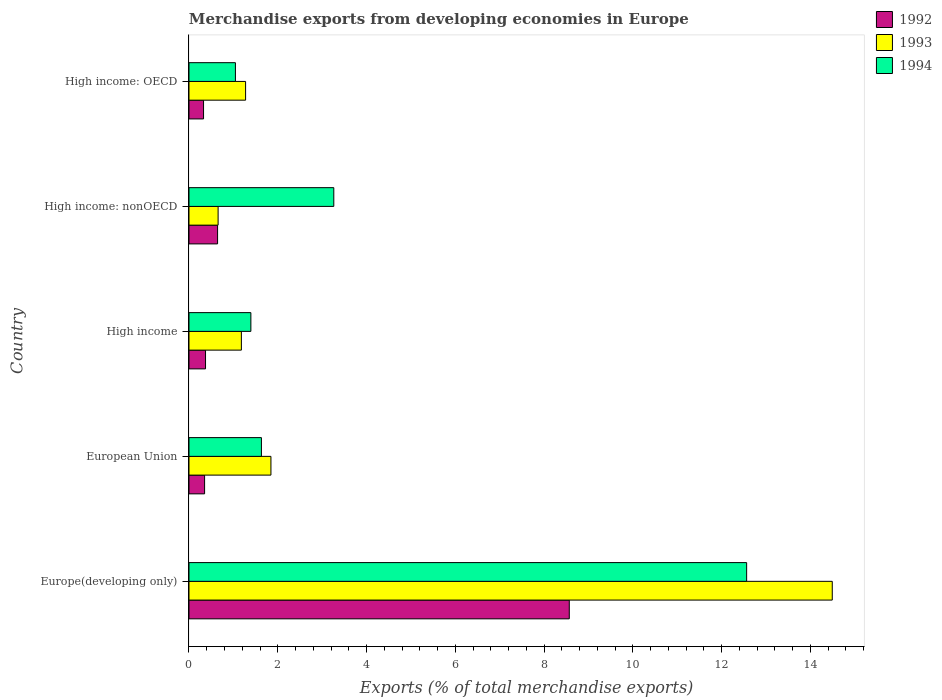How many different coloured bars are there?
Provide a short and direct response. 3. How many groups of bars are there?
Offer a terse response. 5. Are the number of bars per tick equal to the number of legend labels?
Your response must be concise. Yes. Are the number of bars on each tick of the Y-axis equal?
Your answer should be compact. Yes. How many bars are there on the 5th tick from the top?
Keep it short and to the point. 3. How many bars are there on the 5th tick from the bottom?
Keep it short and to the point. 3. What is the label of the 2nd group of bars from the top?
Keep it short and to the point. High income: nonOECD. What is the percentage of total merchandise exports in 1994 in High income: OECD?
Make the answer very short. 1.05. Across all countries, what is the maximum percentage of total merchandise exports in 1994?
Give a very brief answer. 12.57. Across all countries, what is the minimum percentage of total merchandise exports in 1992?
Provide a short and direct response. 0.33. In which country was the percentage of total merchandise exports in 1993 maximum?
Offer a terse response. Europe(developing only). In which country was the percentage of total merchandise exports in 1994 minimum?
Keep it short and to the point. High income: OECD. What is the total percentage of total merchandise exports in 1993 in the graph?
Make the answer very short. 19.45. What is the difference between the percentage of total merchandise exports in 1994 in High income and that in High income: nonOECD?
Ensure brevity in your answer.  -1.87. What is the difference between the percentage of total merchandise exports in 1993 in High income: OECD and the percentage of total merchandise exports in 1992 in European Union?
Provide a short and direct response. 0.92. What is the average percentage of total merchandise exports in 1992 per country?
Offer a very short reply. 2.05. What is the difference between the percentage of total merchandise exports in 1993 and percentage of total merchandise exports in 1994 in European Union?
Offer a terse response. 0.21. In how many countries, is the percentage of total merchandise exports in 1994 greater than 11.6 %?
Your answer should be very brief. 1. What is the ratio of the percentage of total merchandise exports in 1993 in High income to that in High income: OECD?
Offer a very short reply. 0.93. Is the percentage of total merchandise exports in 1993 in Europe(developing only) less than that in European Union?
Keep it short and to the point. No. What is the difference between the highest and the second highest percentage of total merchandise exports in 1994?
Your answer should be compact. 9.3. What is the difference between the highest and the lowest percentage of total merchandise exports in 1993?
Offer a terse response. 13.84. In how many countries, is the percentage of total merchandise exports in 1992 greater than the average percentage of total merchandise exports in 1992 taken over all countries?
Give a very brief answer. 1. What does the 2nd bar from the top in Europe(developing only) represents?
Keep it short and to the point. 1993. Is it the case that in every country, the sum of the percentage of total merchandise exports in 1992 and percentage of total merchandise exports in 1994 is greater than the percentage of total merchandise exports in 1993?
Offer a terse response. Yes. Are all the bars in the graph horizontal?
Keep it short and to the point. Yes. How many countries are there in the graph?
Make the answer very short. 5. What is the difference between two consecutive major ticks on the X-axis?
Your answer should be compact. 2. How are the legend labels stacked?
Offer a very short reply. Vertical. What is the title of the graph?
Make the answer very short. Merchandise exports from developing economies in Europe. Does "1977" appear as one of the legend labels in the graph?
Your answer should be compact. No. What is the label or title of the X-axis?
Offer a very short reply. Exports (% of total merchandise exports). What is the label or title of the Y-axis?
Offer a terse response. Country. What is the Exports (% of total merchandise exports) of 1992 in Europe(developing only)?
Give a very brief answer. 8.57. What is the Exports (% of total merchandise exports) in 1993 in Europe(developing only)?
Your answer should be very brief. 14.5. What is the Exports (% of total merchandise exports) in 1994 in Europe(developing only)?
Make the answer very short. 12.57. What is the Exports (% of total merchandise exports) in 1992 in European Union?
Make the answer very short. 0.35. What is the Exports (% of total merchandise exports) of 1993 in European Union?
Your answer should be very brief. 1.85. What is the Exports (% of total merchandise exports) of 1994 in European Union?
Give a very brief answer. 1.63. What is the Exports (% of total merchandise exports) in 1992 in High income?
Your answer should be compact. 0.37. What is the Exports (% of total merchandise exports) in 1993 in High income?
Give a very brief answer. 1.18. What is the Exports (% of total merchandise exports) in 1994 in High income?
Provide a short and direct response. 1.39. What is the Exports (% of total merchandise exports) in 1992 in High income: nonOECD?
Your response must be concise. 0.64. What is the Exports (% of total merchandise exports) in 1993 in High income: nonOECD?
Offer a terse response. 0.66. What is the Exports (% of total merchandise exports) of 1994 in High income: nonOECD?
Offer a terse response. 3.26. What is the Exports (% of total merchandise exports) in 1992 in High income: OECD?
Keep it short and to the point. 0.33. What is the Exports (% of total merchandise exports) of 1993 in High income: OECD?
Your answer should be very brief. 1.28. What is the Exports (% of total merchandise exports) in 1994 in High income: OECD?
Ensure brevity in your answer.  1.05. Across all countries, what is the maximum Exports (% of total merchandise exports) of 1992?
Your answer should be compact. 8.57. Across all countries, what is the maximum Exports (% of total merchandise exports) in 1993?
Your response must be concise. 14.5. Across all countries, what is the maximum Exports (% of total merchandise exports) of 1994?
Offer a terse response. 12.57. Across all countries, what is the minimum Exports (% of total merchandise exports) of 1992?
Provide a succinct answer. 0.33. Across all countries, what is the minimum Exports (% of total merchandise exports) in 1993?
Keep it short and to the point. 0.66. Across all countries, what is the minimum Exports (% of total merchandise exports) in 1994?
Your response must be concise. 1.05. What is the total Exports (% of total merchandise exports) of 1992 in the graph?
Provide a succinct answer. 10.27. What is the total Exports (% of total merchandise exports) in 1993 in the graph?
Provide a succinct answer. 19.45. What is the total Exports (% of total merchandise exports) in 1994 in the graph?
Your answer should be compact. 19.9. What is the difference between the Exports (% of total merchandise exports) of 1992 in Europe(developing only) and that in European Union?
Your response must be concise. 8.22. What is the difference between the Exports (% of total merchandise exports) in 1993 in Europe(developing only) and that in European Union?
Make the answer very short. 12.65. What is the difference between the Exports (% of total merchandise exports) of 1994 in Europe(developing only) and that in European Union?
Provide a short and direct response. 10.93. What is the difference between the Exports (% of total merchandise exports) in 1992 in Europe(developing only) and that in High income?
Provide a succinct answer. 8.2. What is the difference between the Exports (% of total merchandise exports) in 1993 in Europe(developing only) and that in High income?
Your response must be concise. 13.31. What is the difference between the Exports (% of total merchandise exports) of 1994 in Europe(developing only) and that in High income?
Your answer should be compact. 11.17. What is the difference between the Exports (% of total merchandise exports) of 1992 in Europe(developing only) and that in High income: nonOECD?
Offer a very short reply. 7.92. What is the difference between the Exports (% of total merchandise exports) of 1993 in Europe(developing only) and that in High income: nonOECD?
Give a very brief answer. 13.84. What is the difference between the Exports (% of total merchandise exports) in 1994 in Europe(developing only) and that in High income: nonOECD?
Your answer should be very brief. 9.3. What is the difference between the Exports (% of total merchandise exports) of 1992 in Europe(developing only) and that in High income: OECD?
Keep it short and to the point. 8.24. What is the difference between the Exports (% of total merchandise exports) of 1993 in Europe(developing only) and that in High income: OECD?
Your answer should be compact. 13.22. What is the difference between the Exports (% of total merchandise exports) of 1994 in Europe(developing only) and that in High income: OECD?
Ensure brevity in your answer.  11.52. What is the difference between the Exports (% of total merchandise exports) in 1992 in European Union and that in High income?
Offer a terse response. -0.02. What is the difference between the Exports (% of total merchandise exports) of 1993 in European Union and that in High income?
Your response must be concise. 0.67. What is the difference between the Exports (% of total merchandise exports) of 1994 in European Union and that in High income?
Your answer should be compact. 0.24. What is the difference between the Exports (% of total merchandise exports) in 1992 in European Union and that in High income: nonOECD?
Your answer should be compact. -0.29. What is the difference between the Exports (% of total merchandise exports) in 1993 in European Union and that in High income: nonOECD?
Keep it short and to the point. 1.19. What is the difference between the Exports (% of total merchandise exports) of 1994 in European Union and that in High income: nonOECD?
Give a very brief answer. -1.63. What is the difference between the Exports (% of total merchandise exports) of 1992 in European Union and that in High income: OECD?
Give a very brief answer. 0.02. What is the difference between the Exports (% of total merchandise exports) in 1993 in European Union and that in High income: OECD?
Provide a short and direct response. 0.57. What is the difference between the Exports (% of total merchandise exports) in 1994 in European Union and that in High income: OECD?
Your response must be concise. 0.59. What is the difference between the Exports (% of total merchandise exports) of 1992 in High income and that in High income: nonOECD?
Offer a terse response. -0.27. What is the difference between the Exports (% of total merchandise exports) in 1993 in High income and that in High income: nonOECD?
Give a very brief answer. 0.52. What is the difference between the Exports (% of total merchandise exports) of 1994 in High income and that in High income: nonOECD?
Provide a succinct answer. -1.87. What is the difference between the Exports (% of total merchandise exports) of 1992 in High income and that in High income: OECD?
Provide a short and direct response. 0.04. What is the difference between the Exports (% of total merchandise exports) in 1993 in High income and that in High income: OECD?
Your answer should be very brief. -0.09. What is the difference between the Exports (% of total merchandise exports) in 1994 in High income and that in High income: OECD?
Keep it short and to the point. 0.35. What is the difference between the Exports (% of total merchandise exports) of 1992 in High income: nonOECD and that in High income: OECD?
Ensure brevity in your answer.  0.32. What is the difference between the Exports (% of total merchandise exports) in 1993 in High income: nonOECD and that in High income: OECD?
Your answer should be very brief. -0.62. What is the difference between the Exports (% of total merchandise exports) in 1994 in High income: nonOECD and that in High income: OECD?
Make the answer very short. 2.22. What is the difference between the Exports (% of total merchandise exports) in 1992 in Europe(developing only) and the Exports (% of total merchandise exports) in 1993 in European Union?
Offer a terse response. 6.72. What is the difference between the Exports (% of total merchandise exports) in 1992 in Europe(developing only) and the Exports (% of total merchandise exports) in 1994 in European Union?
Provide a short and direct response. 6.94. What is the difference between the Exports (% of total merchandise exports) in 1993 in Europe(developing only) and the Exports (% of total merchandise exports) in 1994 in European Union?
Make the answer very short. 12.86. What is the difference between the Exports (% of total merchandise exports) in 1992 in Europe(developing only) and the Exports (% of total merchandise exports) in 1993 in High income?
Provide a short and direct response. 7.39. What is the difference between the Exports (% of total merchandise exports) in 1992 in Europe(developing only) and the Exports (% of total merchandise exports) in 1994 in High income?
Ensure brevity in your answer.  7.17. What is the difference between the Exports (% of total merchandise exports) in 1993 in Europe(developing only) and the Exports (% of total merchandise exports) in 1994 in High income?
Offer a very short reply. 13.1. What is the difference between the Exports (% of total merchandise exports) in 1992 in Europe(developing only) and the Exports (% of total merchandise exports) in 1993 in High income: nonOECD?
Your answer should be very brief. 7.91. What is the difference between the Exports (% of total merchandise exports) of 1992 in Europe(developing only) and the Exports (% of total merchandise exports) of 1994 in High income: nonOECD?
Provide a short and direct response. 5.31. What is the difference between the Exports (% of total merchandise exports) in 1993 in Europe(developing only) and the Exports (% of total merchandise exports) in 1994 in High income: nonOECD?
Ensure brevity in your answer.  11.23. What is the difference between the Exports (% of total merchandise exports) of 1992 in Europe(developing only) and the Exports (% of total merchandise exports) of 1993 in High income: OECD?
Keep it short and to the point. 7.29. What is the difference between the Exports (% of total merchandise exports) of 1992 in Europe(developing only) and the Exports (% of total merchandise exports) of 1994 in High income: OECD?
Your answer should be compact. 7.52. What is the difference between the Exports (% of total merchandise exports) of 1993 in Europe(developing only) and the Exports (% of total merchandise exports) of 1994 in High income: OECD?
Offer a terse response. 13.45. What is the difference between the Exports (% of total merchandise exports) of 1992 in European Union and the Exports (% of total merchandise exports) of 1993 in High income?
Your response must be concise. -0.83. What is the difference between the Exports (% of total merchandise exports) of 1992 in European Union and the Exports (% of total merchandise exports) of 1994 in High income?
Give a very brief answer. -1.04. What is the difference between the Exports (% of total merchandise exports) of 1993 in European Union and the Exports (% of total merchandise exports) of 1994 in High income?
Offer a very short reply. 0.45. What is the difference between the Exports (% of total merchandise exports) in 1992 in European Union and the Exports (% of total merchandise exports) in 1993 in High income: nonOECD?
Give a very brief answer. -0.3. What is the difference between the Exports (% of total merchandise exports) of 1992 in European Union and the Exports (% of total merchandise exports) of 1994 in High income: nonOECD?
Your response must be concise. -2.91. What is the difference between the Exports (% of total merchandise exports) in 1993 in European Union and the Exports (% of total merchandise exports) in 1994 in High income: nonOECD?
Offer a very short reply. -1.42. What is the difference between the Exports (% of total merchandise exports) of 1992 in European Union and the Exports (% of total merchandise exports) of 1993 in High income: OECD?
Give a very brief answer. -0.92. What is the difference between the Exports (% of total merchandise exports) of 1992 in European Union and the Exports (% of total merchandise exports) of 1994 in High income: OECD?
Your answer should be compact. -0.69. What is the difference between the Exports (% of total merchandise exports) in 1993 in European Union and the Exports (% of total merchandise exports) in 1994 in High income: OECD?
Ensure brevity in your answer.  0.8. What is the difference between the Exports (% of total merchandise exports) of 1992 in High income and the Exports (% of total merchandise exports) of 1993 in High income: nonOECD?
Provide a succinct answer. -0.28. What is the difference between the Exports (% of total merchandise exports) of 1992 in High income and the Exports (% of total merchandise exports) of 1994 in High income: nonOECD?
Ensure brevity in your answer.  -2.89. What is the difference between the Exports (% of total merchandise exports) in 1993 in High income and the Exports (% of total merchandise exports) in 1994 in High income: nonOECD?
Provide a short and direct response. -2.08. What is the difference between the Exports (% of total merchandise exports) of 1992 in High income and the Exports (% of total merchandise exports) of 1993 in High income: OECD?
Your answer should be very brief. -0.9. What is the difference between the Exports (% of total merchandise exports) in 1992 in High income and the Exports (% of total merchandise exports) in 1994 in High income: OECD?
Provide a short and direct response. -0.67. What is the difference between the Exports (% of total merchandise exports) of 1993 in High income and the Exports (% of total merchandise exports) of 1994 in High income: OECD?
Your answer should be very brief. 0.13. What is the difference between the Exports (% of total merchandise exports) of 1992 in High income: nonOECD and the Exports (% of total merchandise exports) of 1993 in High income: OECD?
Provide a succinct answer. -0.63. What is the difference between the Exports (% of total merchandise exports) of 1992 in High income: nonOECD and the Exports (% of total merchandise exports) of 1994 in High income: OECD?
Give a very brief answer. -0.4. What is the difference between the Exports (% of total merchandise exports) in 1993 in High income: nonOECD and the Exports (% of total merchandise exports) in 1994 in High income: OECD?
Your answer should be very brief. -0.39. What is the average Exports (% of total merchandise exports) in 1992 per country?
Provide a succinct answer. 2.05. What is the average Exports (% of total merchandise exports) in 1993 per country?
Your response must be concise. 3.89. What is the average Exports (% of total merchandise exports) of 1994 per country?
Make the answer very short. 3.98. What is the difference between the Exports (% of total merchandise exports) of 1992 and Exports (% of total merchandise exports) of 1993 in Europe(developing only)?
Ensure brevity in your answer.  -5.93. What is the difference between the Exports (% of total merchandise exports) of 1992 and Exports (% of total merchandise exports) of 1994 in Europe(developing only)?
Offer a terse response. -4. What is the difference between the Exports (% of total merchandise exports) in 1993 and Exports (% of total merchandise exports) in 1994 in Europe(developing only)?
Offer a terse response. 1.93. What is the difference between the Exports (% of total merchandise exports) of 1992 and Exports (% of total merchandise exports) of 1993 in European Union?
Your response must be concise. -1.49. What is the difference between the Exports (% of total merchandise exports) in 1992 and Exports (% of total merchandise exports) in 1994 in European Union?
Ensure brevity in your answer.  -1.28. What is the difference between the Exports (% of total merchandise exports) in 1993 and Exports (% of total merchandise exports) in 1994 in European Union?
Give a very brief answer. 0.21. What is the difference between the Exports (% of total merchandise exports) in 1992 and Exports (% of total merchandise exports) in 1993 in High income?
Make the answer very short. -0.81. What is the difference between the Exports (% of total merchandise exports) in 1992 and Exports (% of total merchandise exports) in 1994 in High income?
Keep it short and to the point. -1.02. What is the difference between the Exports (% of total merchandise exports) of 1993 and Exports (% of total merchandise exports) of 1994 in High income?
Offer a very short reply. -0.21. What is the difference between the Exports (% of total merchandise exports) of 1992 and Exports (% of total merchandise exports) of 1993 in High income: nonOECD?
Make the answer very short. -0.01. What is the difference between the Exports (% of total merchandise exports) of 1992 and Exports (% of total merchandise exports) of 1994 in High income: nonOECD?
Ensure brevity in your answer.  -2.62. What is the difference between the Exports (% of total merchandise exports) in 1993 and Exports (% of total merchandise exports) in 1994 in High income: nonOECD?
Keep it short and to the point. -2.61. What is the difference between the Exports (% of total merchandise exports) in 1992 and Exports (% of total merchandise exports) in 1993 in High income: OECD?
Offer a terse response. -0.95. What is the difference between the Exports (% of total merchandise exports) in 1992 and Exports (% of total merchandise exports) in 1994 in High income: OECD?
Provide a short and direct response. -0.72. What is the difference between the Exports (% of total merchandise exports) of 1993 and Exports (% of total merchandise exports) of 1994 in High income: OECD?
Your answer should be very brief. 0.23. What is the ratio of the Exports (% of total merchandise exports) in 1992 in Europe(developing only) to that in European Union?
Ensure brevity in your answer.  24.36. What is the ratio of the Exports (% of total merchandise exports) in 1993 in Europe(developing only) to that in European Union?
Make the answer very short. 7.85. What is the ratio of the Exports (% of total merchandise exports) of 1994 in Europe(developing only) to that in European Union?
Ensure brevity in your answer.  7.7. What is the ratio of the Exports (% of total merchandise exports) of 1992 in Europe(developing only) to that in High income?
Your answer should be very brief. 22.99. What is the ratio of the Exports (% of total merchandise exports) of 1993 in Europe(developing only) to that in High income?
Make the answer very short. 12.28. What is the ratio of the Exports (% of total merchandise exports) in 1994 in Europe(developing only) to that in High income?
Provide a succinct answer. 9.01. What is the ratio of the Exports (% of total merchandise exports) in 1992 in Europe(developing only) to that in High income: nonOECD?
Offer a very short reply. 13.3. What is the ratio of the Exports (% of total merchandise exports) in 1993 in Europe(developing only) to that in High income: nonOECD?
Provide a short and direct response. 22.09. What is the ratio of the Exports (% of total merchandise exports) of 1994 in Europe(developing only) to that in High income: nonOECD?
Your answer should be very brief. 3.85. What is the ratio of the Exports (% of total merchandise exports) of 1992 in Europe(developing only) to that in High income: OECD?
Make the answer very short. 26.12. What is the ratio of the Exports (% of total merchandise exports) in 1993 in Europe(developing only) to that in High income: OECD?
Your response must be concise. 11.37. What is the ratio of the Exports (% of total merchandise exports) of 1994 in Europe(developing only) to that in High income: OECD?
Ensure brevity in your answer.  12.01. What is the ratio of the Exports (% of total merchandise exports) in 1992 in European Union to that in High income?
Your answer should be compact. 0.94. What is the ratio of the Exports (% of total merchandise exports) in 1993 in European Union to that in High income?
Provide a short and direct response. 1.56. What is the ratio of the Exports (% of total merchandise exports) of 1994 in European Union to that in High income?
Keep it short and to the point. 1.17. What is the ratio of the Exports (% of total merchandise exports) in 1992 in European Union to that in High income: nonOECD?
Offer a very short reply. 0.55. What is the ratio of the Exports (% of total merchandise exports) in 1993 in European Union to that in High income: nonOECD?
Offer a terse response. 2.81. What is the ratio of the Exports (% of total merchandise exports) of 1994 in European Union to that in High income: nonOECD?
Offer a terse response. 0.5. What is the ratio of the Exports (% of total merchandise exports) of 1992 in European Union to that in High income: OECD?
Your response must be concise. 1.07. What is the ratio of the Exports (% of total merchandise exports) in 1993 in European Union to that in High income: OECD?
Provide a succinct answer. 1.45. What is the ratio of the Exports (% of total merchandise exports) of 1994 in European Union to that in High income: OECD?
Offer a very short reply. 1.56. What is the ratio of the Exports (% of total merchandise exports) of 1992 in High income to that in High income: nonOECD?
Make the answer very short. 0.58. What is the ratio of the Exports (% of total merchandise exports) of 1993 in High income to that in High income: nonOECD?
Provide a short and direct response. 1.8. What is the ratio of the Exports (% of total merchandise exports) of 1994 in High income to that in High income: nonOECD?
Your response must be concise. 0.43. What is the ratio of the Exports (% of total merchandise exports) in 1992 in High income to that in High income: OECD?
Your response must be concise. 1.14. What is the ratio of the Exports (% of total merchandise exports) in 1993 in High income to that in High income: OECD?
Give a very brief answer. 0.93. What is the ratio of the Exports (% of total merchandise exports) of 1994 in High income to that in High income: OECD?
Offer a very short reply. 1.33. What is the ratio of the Exports (% of total merchandise exports) in 1992 in High income: nonOECD to that in High income: OECD?
Your answer should be compact. 1.96. What is the ratio of the Exports (% of total merchandise exports) in 1993 in High income: nonOECD to that in High income: OECD?
Make the answer very short. 0.51. What is the ratio of the Exports (% of total merchandise exports) of 1994 in High income: nonOECD to that in High income: OECD?
Your response must be concise. 3.12. What is the difference between the highest and the second highest Exports (% of total merchandise exports) in 1992?
Offer a very short reply. 7.92. What is the difference between the highest and the second highest Exports (% of total merchandise exports) of 1993?
Offer a very short reply. 12.65. What is the difference between the highest and the second highest Exports (% of total merchandise exports) in 1994?
Your answer should be very brief. 9.3. What is the difference between the highest and the lowest Exports (% of total merchandise exports) of 1992?
Your response must be concise. 8.24. What is the difference between the highest and the lowest Exports (% of total merchandise exports) of 1993?
Keep it short and to the point. 13.84. What is the difference between the highest and the lowest Exports (% of total merchandise exports) of 1994?
Your answer should be compact. 11.52. 